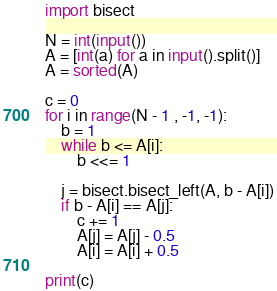Convert code to text. <code><loc_0><loc_0><loc_500><loc_500><_Python_>import bisect

N = int(input())
A = [int(a) for a in input().split()]
A = sorted(A)

c = 0
for i in range(N - 1 , -1, -1):
    b = 1
    while b <= A[i]:
        b <<= 1
    
    j = bisect.bisect_left(A, b - A[i])
    if b - A[i] == A[j]:
        c += 1
        A[j] = A[j] - 0.5
        A[i] = A[i] + 0.5

print(c)
</code> 